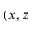Convert formula to latex. <formula><loc_0><loc_0><loc_500><loc_500>( x , z</formula> 